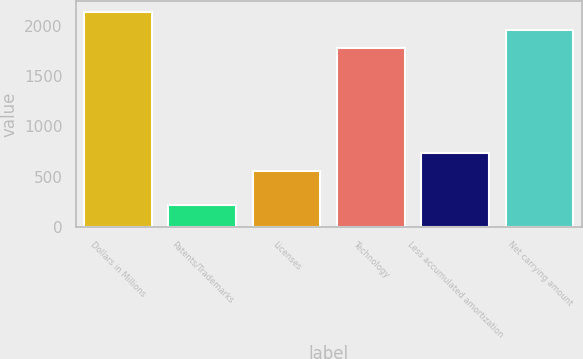Convert chart to OTSL. <chart><loc_0><loc_0><loc_500><loc_500><bar_chart><fcel>Dollars in Millions<fcel>Patents/Trademarks<fcel>Licenses<fcel>Technology<fcel>Less accumulated amortization<fcel>Net carrying amount<nl><fcel>2140.6<fcel>214<fcel>554<fcel>1783<fcel>732.8<fcel>1961.8<nl></chart> 